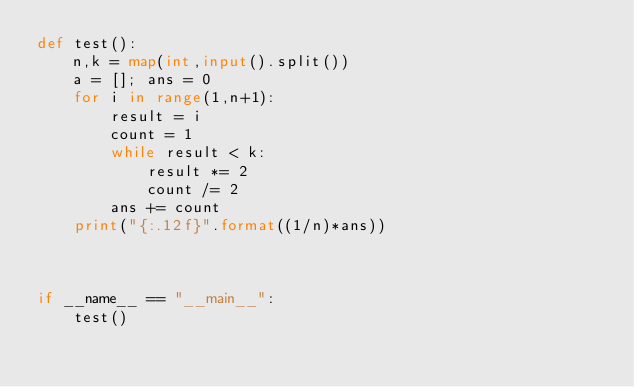<code> <loc_0><loc_0><loc_500><loc_500><_Python_>def test():
    n,k = map(int,input().split())
    a = []; ans = 0
    for i in range(1,n+1):
        result = i
        count = 1
        while result < k:
            result *= 2
            count /= 2
        ans += count
    print("{:.12f}".format((1/n)*ans))



if __name__ == "__main__":
    test()
</code> 